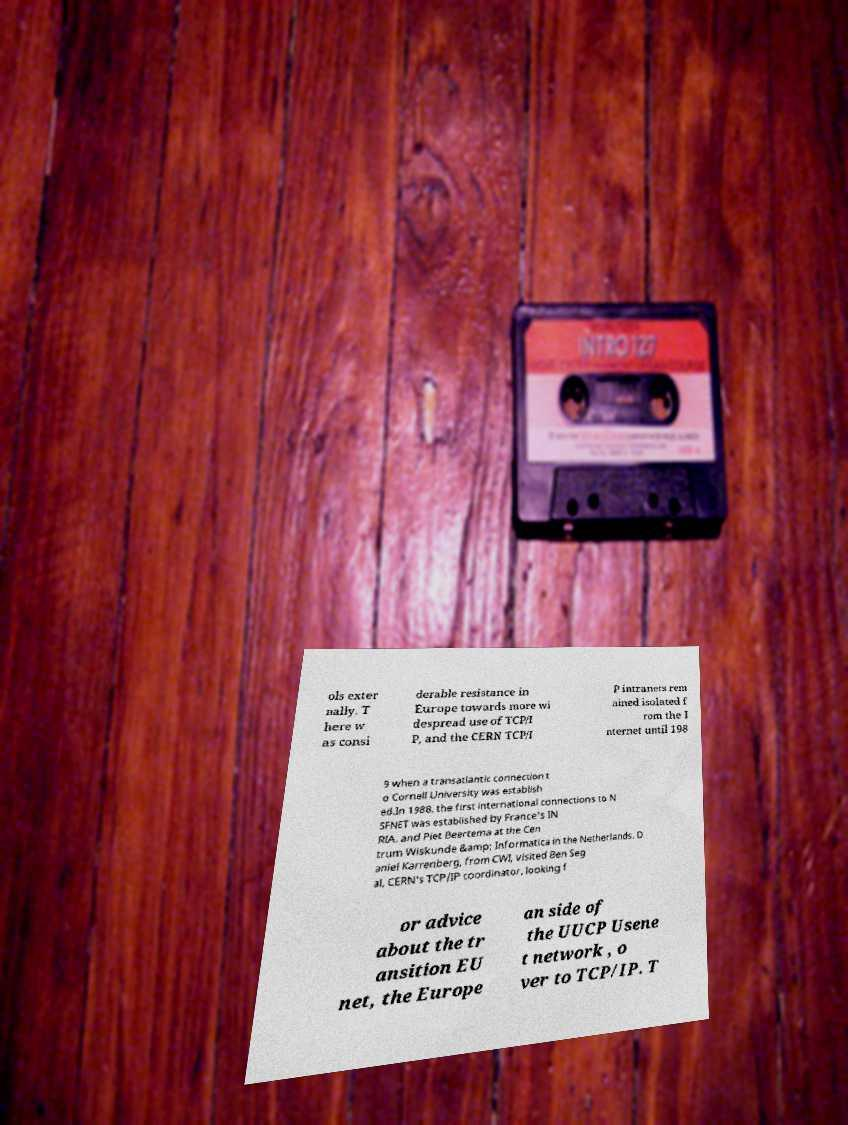Could you assist in decoding the text presented in this image and type it out clearly? ols exter nally. T here w as consi derable resistance in Europe towards more wi despread use of TCP/I P, and the CERN TCP/I P intranets rem ained isolated f rom the I nternet until 198 9 when a transatlantic connection t o Cornell University was establish ed.In 1988, the first international connections to N SFNET was established by France's IN RIA, and Piet Beertema at the Cen trum Wiskunde &amp; Informatica in the Netherlands. D aniel Karrenberg, from CWI, visited Ben Seg al, CERN's TCP/IP coordinator, looking f or advice about the tr ansition EU net, the Europe an side of the UUCP Usene t network , o ver to TCP/IP. T 